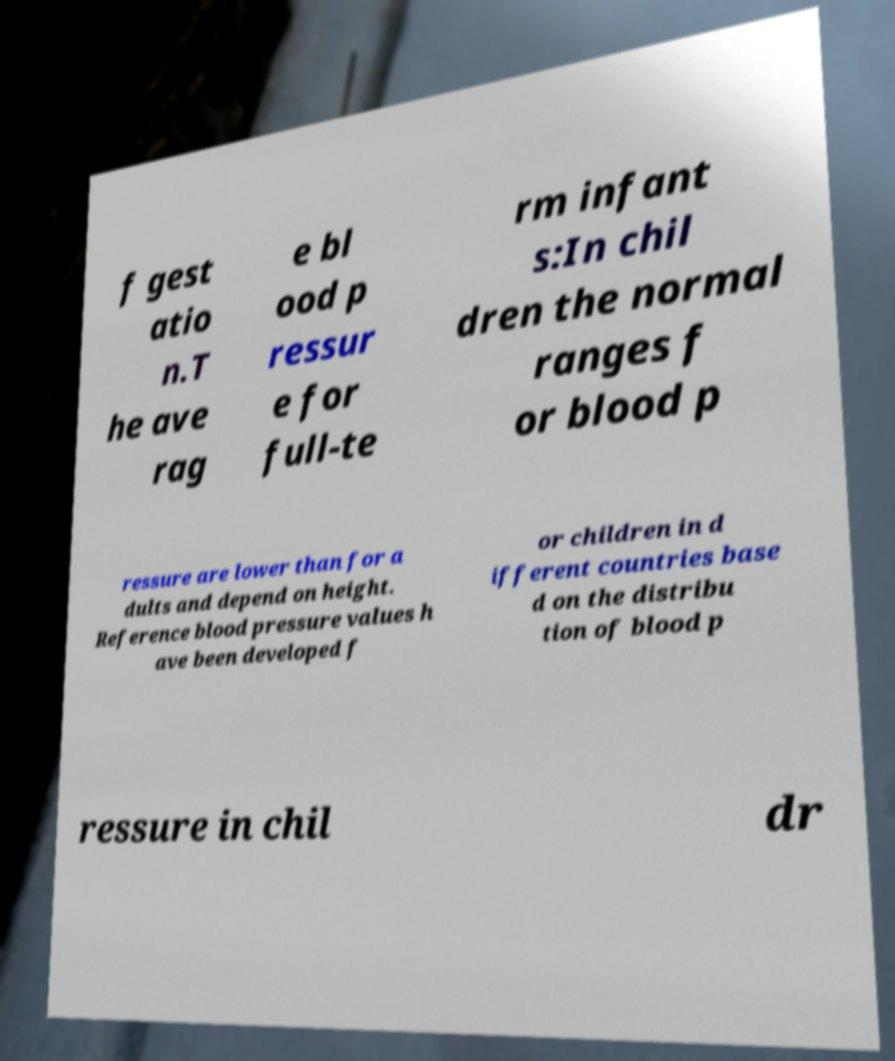What messages or text are displayed in this image? I need them in a readable, typed format. f gest atio n.T he ave rag e bl ood p ressur e for full-te rm infant s:In chil dren the normal ranges f or blood p ressure are lower than for a dults and depend on height. Reference blood pressure values h ave been developed f or children in d ifferent countries base d on the distribu tion of blood p ressure in chil dr 